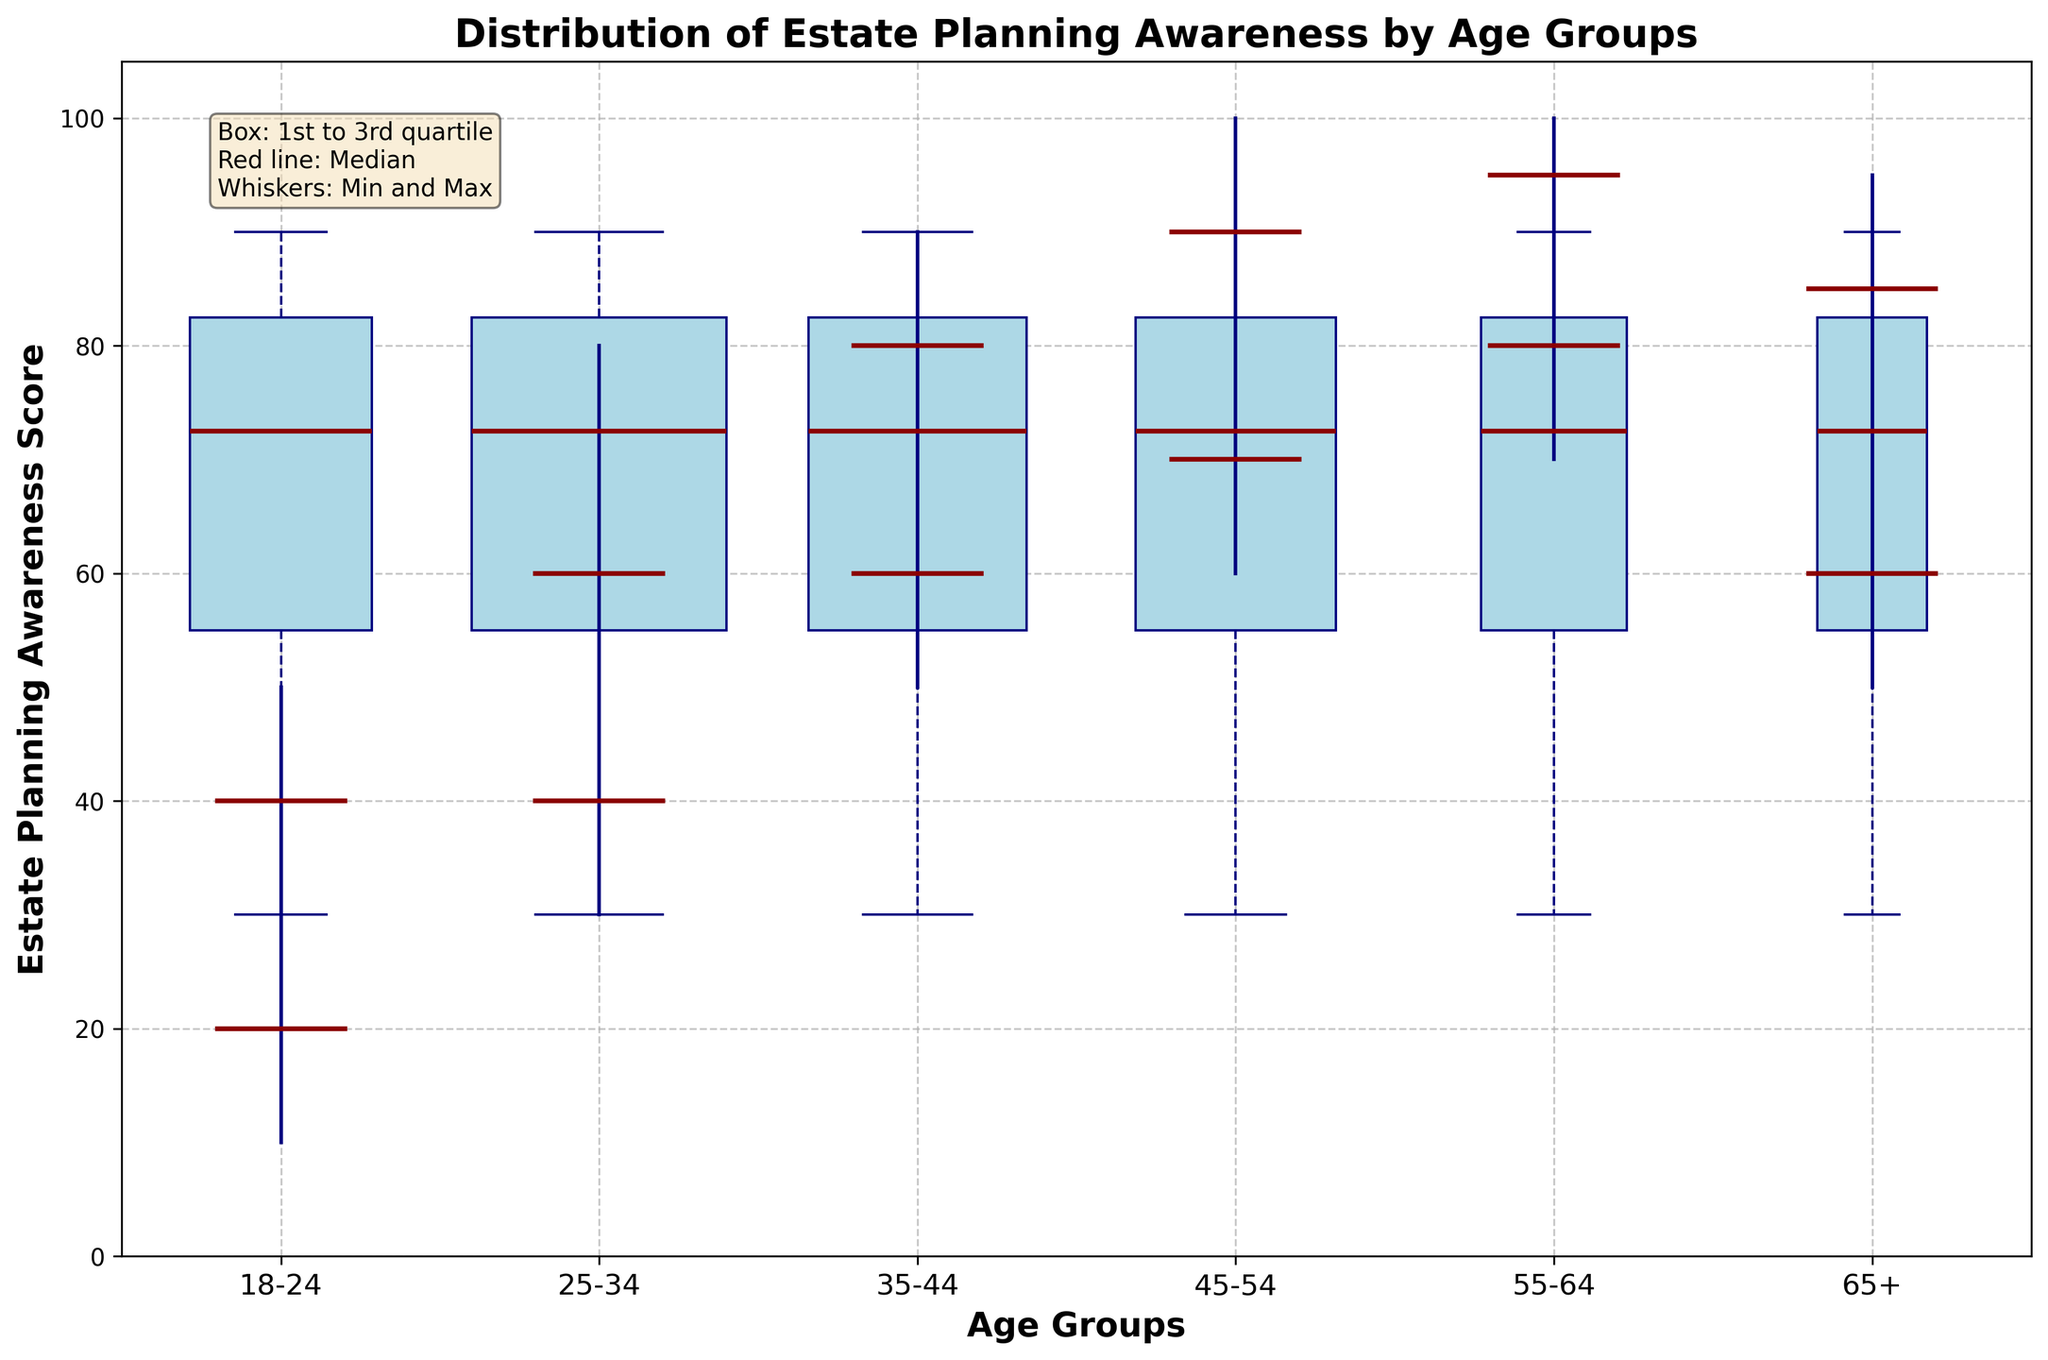what is the title of the figure? The title is usually located at the top of the figure. For this plot, it reads "Distribution of Estate Planning Awareness by Age Groups".
Answer: Distribution of Estate Planning Awareness by Age Groups What do the whiskers represent in the plot? The whiskers represent the minimum and maximum awareness scores within each age group. This is visually indicated by the vertical lines extending from the boxes.
Answer: Min and Max scores Which age group has the highest median estate planning awareness score? You can find the median score by looking at the central horizontal line within each box. The "55-64" age group has the highest median, which is at 90.
Answer: 55-64 What is the median awareness score for the 35-44 age group? The median score is indicated by the central line inside the box for each age group. For the 35-44 age group, it is 70.
Answer: 70 Which age group shows the widest range of estate planning awareness? The range is reflected by the distance between the minimum and maximum whiskers. The age group "25-34" shows the widest range, spanning from 30 to 80.
Answer: 25-34 What is the interquartile range (IQR) for the 18-24 age group? The interquartile range is calculated as the difference between the third quartile (Q3) value and the first quartile (Q1) value. For the 18-24 age group, Q3 is 40 and Q1 is 20, so the IQR = 40 - 20 = 20.
Answer: 20 Which age group has the smallest sample size? The thickness of the box reflects the sample size, and the thinnest box indicates the smallest sample size. The "65+" age group has the smallest sample size.
Answer: 65+ Compare the median awareness scores of the 45-54 and 65+ age groups. Which one is higher? Compare the medians by looking at the central lines within the boxes for these age groups. The median for "45-54" is higher at 85, compared to the "65+" median of 75.
Answer: 45-54 Is there any age group with an awareness score below 20? The minimum awareness score can be derived from the bottom whisker for each age group. The "18-24" age group has a minimum score of 10, which is below 20.
Answer: Yes 